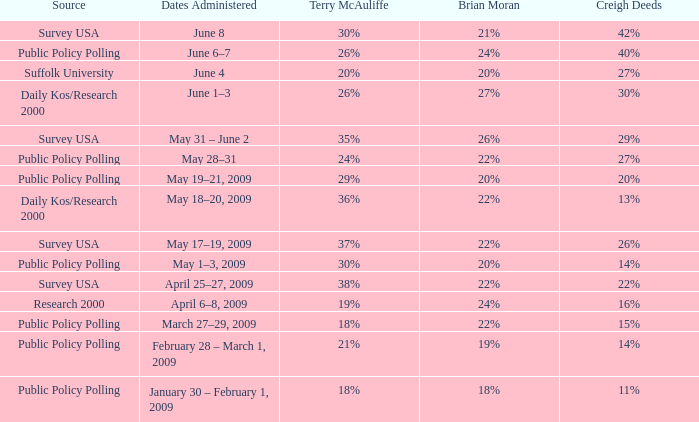Which Source has a Brian Moran of 19%? Public Policy Polling. 